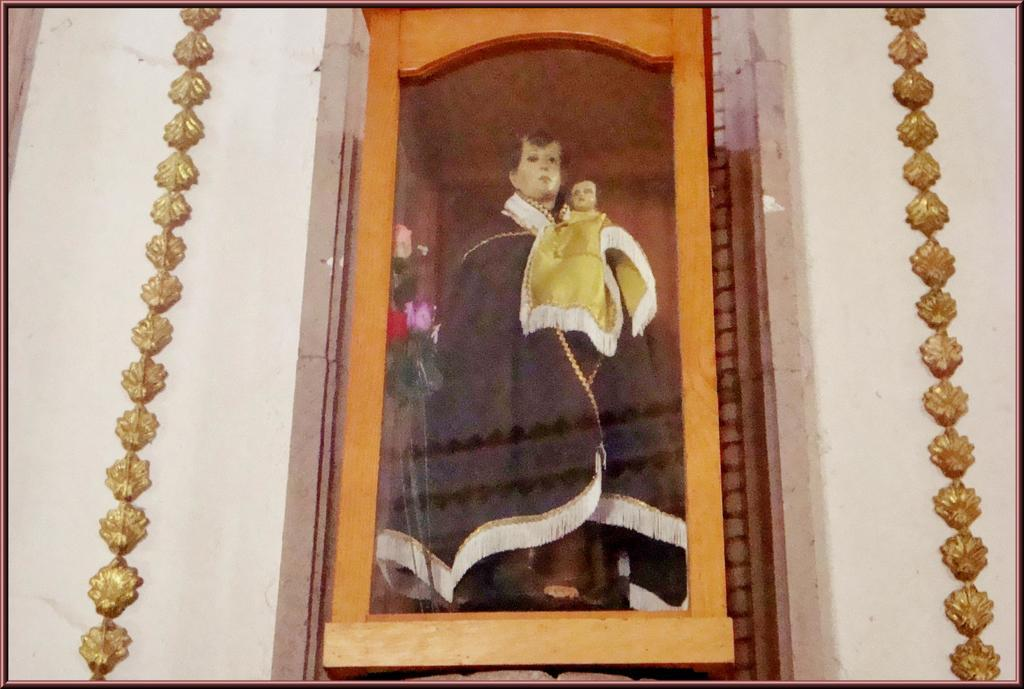What is the statue of in the image? The statue is of a person holding a baby in a box. What is visible in the background of the image? There is a wall visible in the image. What type of skirt is the judge wearing in the image? There is no judge or skirt present in the image. What type of cast is visible on the statue's arm in the image? There is no cast visible on the statue's arm in the image. 